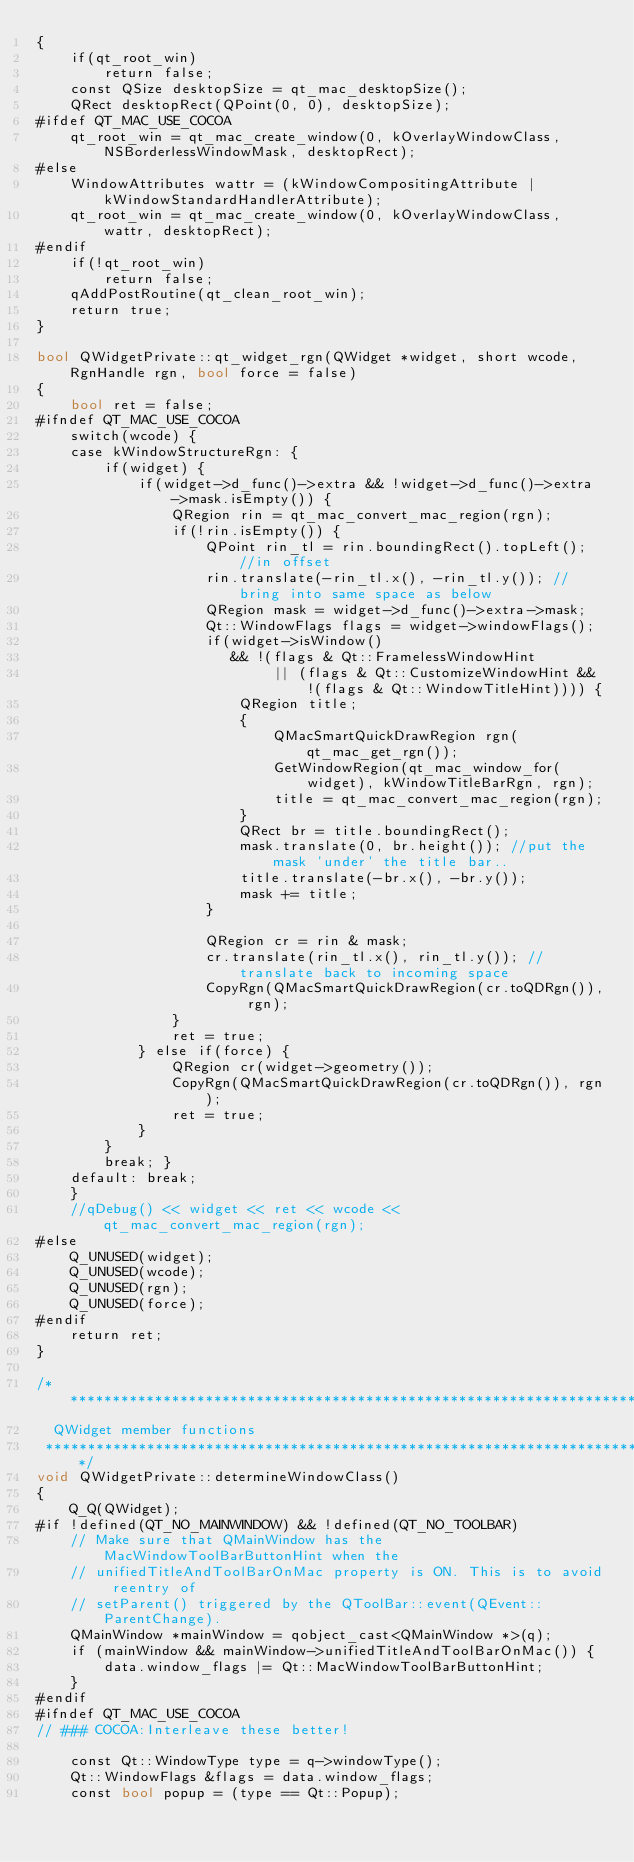Convert code to text. <code><loc_0><loc_0><loc_500><loc_500><_ObjectiveC_>{
    if(qt_root_win)
        return false;
    const QSize desktopSize = qt_mac_desktopSize();
    QRect desktopRect(QPoint(0, 0), desktopSize);
#ifdef QT_MAC_USE_COCOA
    qt_root_win = qt_mac_create_window(0, kOverlayWindowClass, NSBorderlessWindowMask, desktopRect);
#else
    WindowAttributes wattr = (kWindowCompositingAttribute | kWindowStandardHandlerAttribute);
    qt_root_win = qt_mac_create_window(0, kOverlayWindowClass, wattr, desktopRect);
#endif
    if(!qt_root_win)
        return false;
    qAddPostRoutine(qt_clean_root_win);
    return true;
}

bool QWidgetPrivate::qt_widget_rgn(QWidget *widget, short wcode, RgnHandle rgn, bool force = false)
{
    bool ret = false;
#ifndef QT_MAC_USE_COCOA
    switch(wcode) {
    case kWindowStructureRgn: {
        if(widget) {
            if(widget->d_func()->extra && !widget->d_func()->extra->mask.isEmpty()) {
                QRegion rin = qt_mac_convert_mac_region(rgn);
                if(!rin.isEmpty()) {
                    QPoint rin_tl = rin.boundingRect().topLeft(); //in offset
                    rin.translate(-rin_tl.x(), -rin_tl.y()); //bring into same space as below
                    QRegion mask = widget->d_func()->extra->mask;
                    Qt::WindowFlags flags = widget->windowFlags();
                    if(widget->isWindow()
                       && !(flags & Qt::FramelessWindowHint
                            || (flags & Qt::CustomizeWindowHint && !(flags & Qt::WindowTitleHint)))) {
                        QRegion title;
                        {
                            QMacSmartQuickDrawRegion rgn(qt_mac_get_rgn());
                            GetWindowRegion(qt_mac_window_for(widget), kWindowTitleBarRgn, rgn);
                            title = qt_mac_convert_mac_region(rgn);
                        }
                        QRect br = title.boundingRect();
                        mask.translate(0, br.height()); //put the mask 'under' the title bar..
                        title.translate(-br.x(), -br.y());
                        mask += title;
                    }

                    QRegion cr = rin & mask;
                    cr.translate(rin_tl.x(), rin_tl.y()); //translate back to incoming space
                    CopyRgn(QMacSmartQuickDrawRegion(cr.toQDRgn()), rgn);
                }
                ret = true;
            } else if(force) {
                QRegion cr(widget->geometry());
                CopyRgn(QMacSmartQuickDrawRegion(cr.toQDRgn()), rgn);
                ret = true;
            }
        }
        break; }
    default: break;
    }
    //qDebug() << widget << ret << wcode << qt_mac_convert_mac_region(rgn);
#else
    Q_UNUSED(widget);
    Q_UNUSED(wcode);
    Q_UNUSED(rgn);
    Q_UNUSED(force);
#endif
    return ret;
}

/*****************************************************************************
  QWidget member functions
 *****************************************************************************/
void QWidgetPrivate::determineWindowClass()
{
    Q_Q(QWidget);
#if !defined(QT_NO_MAINWINDOW) && !defined(QT_NO_TOOLBAR)
    // Make sure that QMainWindow has the MacWindowToolBarButtonHint when the
    // unifiedTitleAndToolBarOnMac property is ON. This is to avoid reentry of
    // setParent() triggered by the QToolBar::event(QEvent::ParentChange).
    QMainWindow *mainWindow = qobject_cast<QMainWindow *>(q);
    if (mainWindow && mainWindow->unifiedTitleAndToolBarOnMac()) {
        data.window_flags |= Qt::MacWindowToolBarButtonHint;
    }
#endif
#ifndef QT_MAC_USE_COCOA
// ### COCOA:Interleave these better!

    const Qt::WindowType type = q->windowType();
    Qt::WindowFlags &flags = data.window_flags;
    const bool popup = (type == Qt::Popup);</code> 